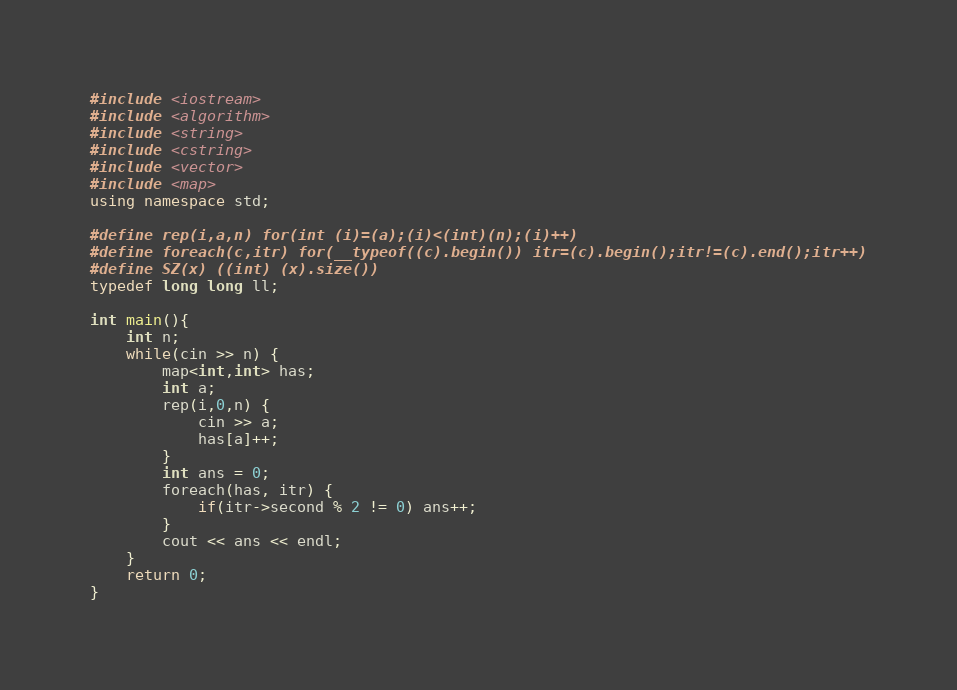Convert code to text. <code><loc_0><loc_0><loc_500><loc_500><_C++_>#include <iostream>
#include <algorithm>
#include <string>
#include <cstring>
#include <vector>
#include <map>
using namespace std;

#define rep(i,a,n) for(int (i)=(a);(i)<(int)(n);(i)++)
#define foreach(c,itr) for(__typeof((c).begin()) itr=(c).begin();itr!=(c).end();itr++)
#define SZ(x) ((int) (x).size())
typedef long long ll;

int main(){
	int n;
	while(cin >> n) {
		map<int,int> has;
		int a;
		rep(i,0,n) {
			cin >> a;
			has[a]++;
		}
		int ans = 0;
		foreach(has, itr) {
			if(itr->second % 2 != 0) ans++;
		}
		cout << ans << endl;
	}
    return 0;
}
</code> 